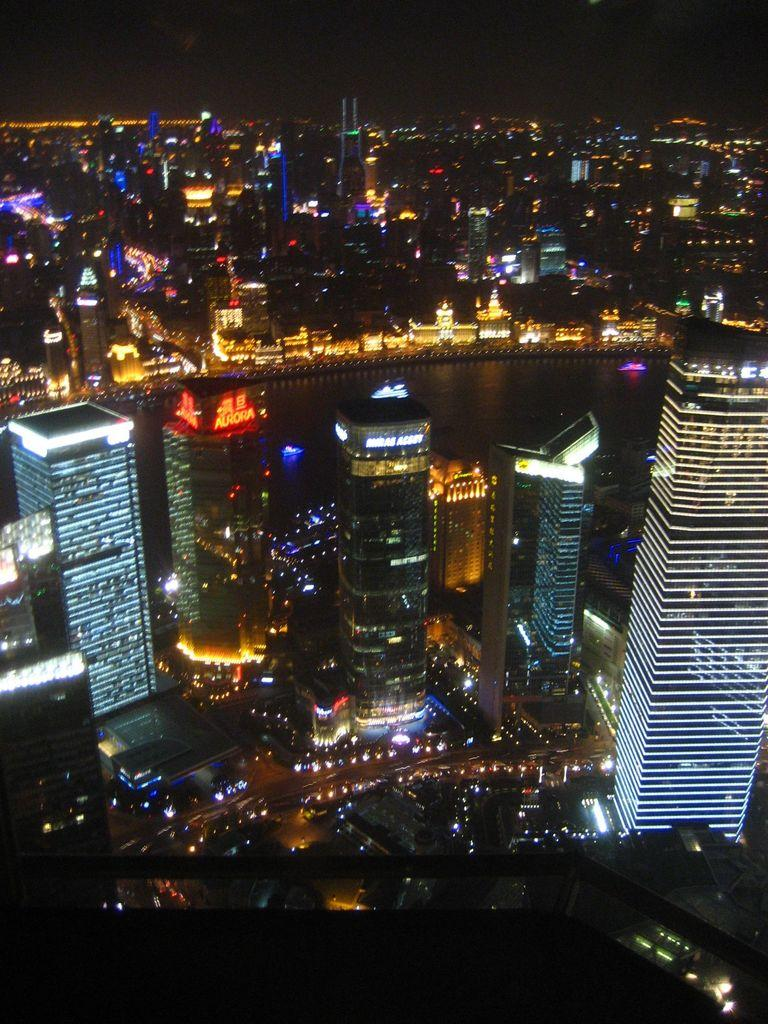What type of structures can be seen in the image? There are multiple buildings in the image. What colors are the lights in the image? The lights in the image are in various colors, including orange, blue, red, and white. What natural element is visible in the image? There is water visible in the image. What part of the sky can be seen in the image? The sky is visible in the image. How does the truck turn the yoke in the image? There is no truck or yoke present in the image. 